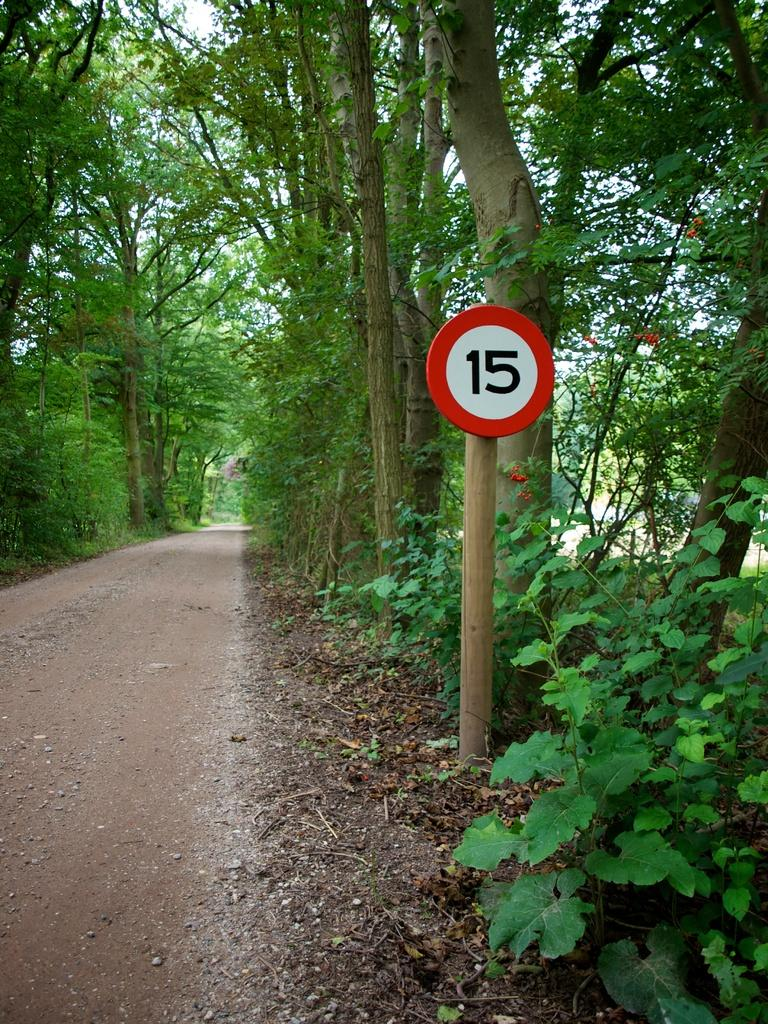Provide a one-sentence caption for the provided image. A sign with the number 15 on it on a roadside in the forest. 